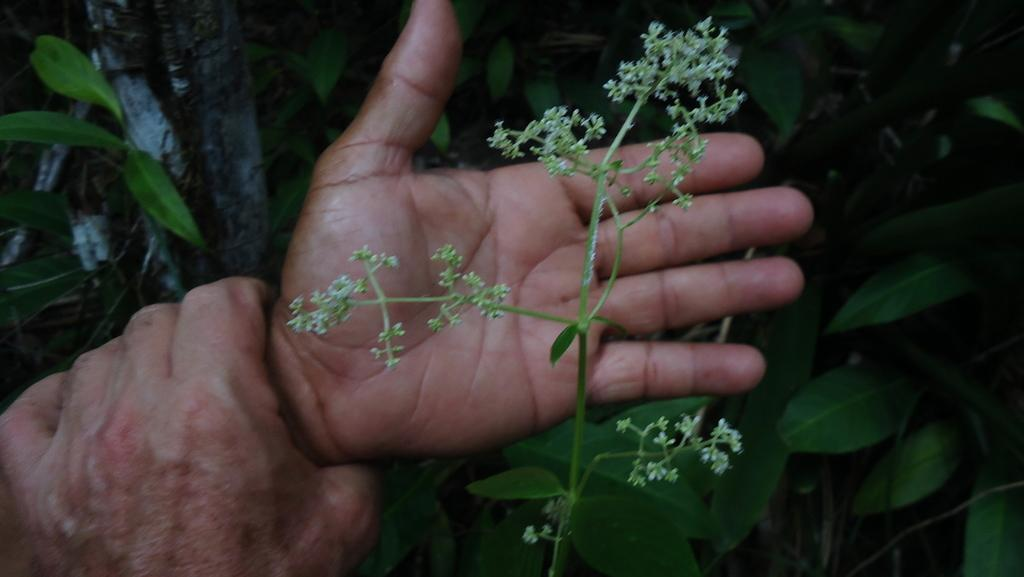What is the person holding in the image? There is a flower stem in a person's hand in the image. What else can be seen in the image besides the person holding the flower stem? There are plants present in the image. What type of vein can be seen running through the car in the image? There is no car present in the image, so there are no veins to be seen running through it. 